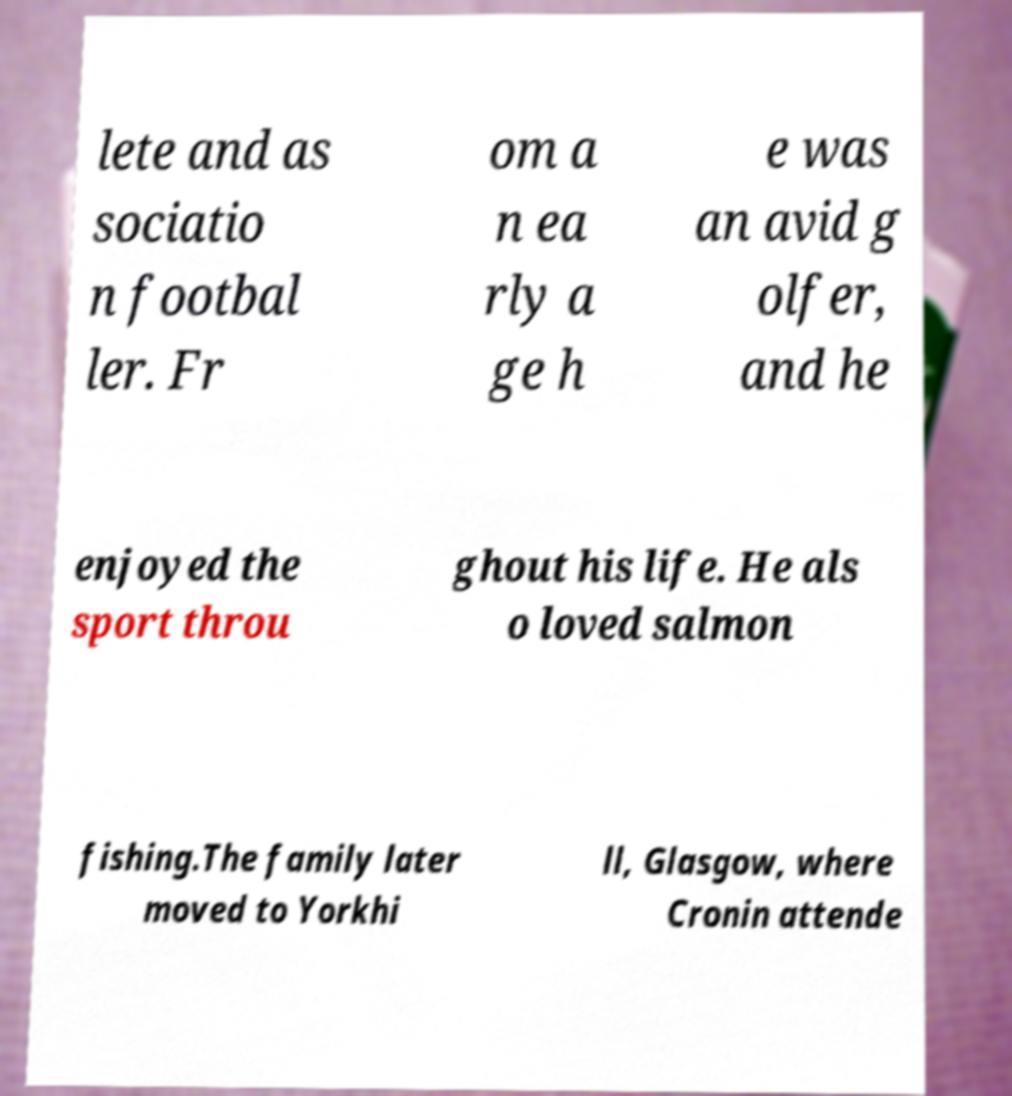What messages or text are displayed in this image? I need them in a readable, typed format. lete and as sociatio n footbal ler. Fr om a n ea rly a ge h e was an avid g olfer, and he enjoyed the sport throu ghout his life. He als o loved salmon fishing.The family later moved to Yorkhi ll, Glasgow, where Cronin attende 